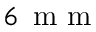Convert formula to latex. <formula><loc_0><loc_0><loc_500><loc_500>6 \, m m</formula> 